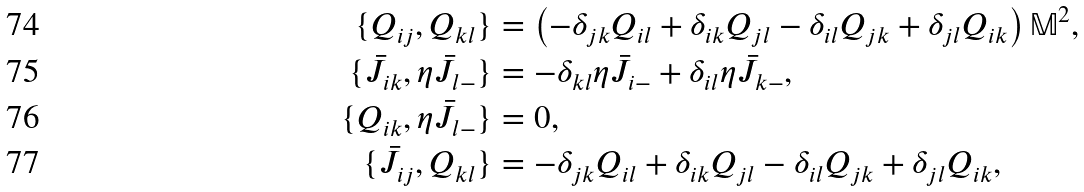<formula> <loc_0><loc_0><loc_500><loc_500>\{ Q _ { i j } , Q _ { k l } \} & = \left ( - \delta _ { j k } Q _ { i l } + \delta _ { i k } Q _ { j l } - \delta _ { i l } Q _ { j k } + \delta _ { j l } Q _ { i k } \right ) \mathbb { M } ^ { 2 } , \\ \{ \bar { J } _ { i k } , \eta \bar { J } _ { l - } \} & = - \delta _ { k l } \eta \bar { J } _ { i - } + \delta _ { i l } \eta \bar { J } _ { k - } , \\ \{ Q _ { i k } , \eta \bar { J } _ { l - } \} & = 0 , \\ \{ \bar { J } _ { i j } , Q _ { k l } \} & = - \delta _ { j k } Q _ { i l } + \delta _ { i k } Q _ { j l } - \delta _ { i l } Q _ { j k } + \delta _ { j l } Q _ { i k } ,</formula> 